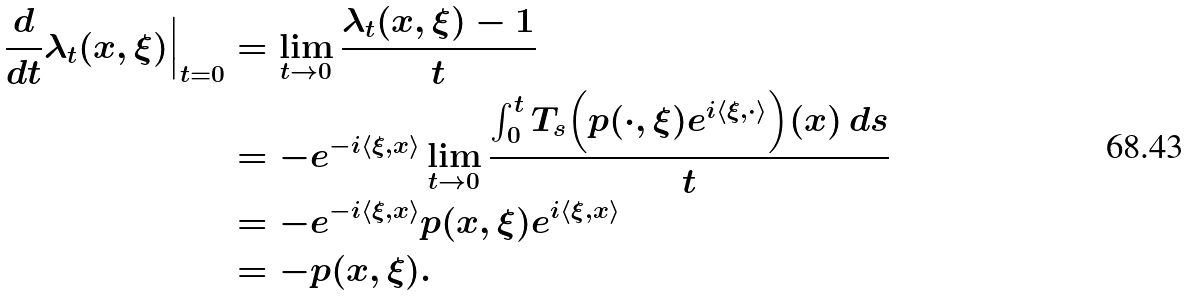Convert formula to latex. <formula><loc_0><loc_0><loc_500><loc_500>\frac { d } { d t } \lambda _ { t } ( x , \xi ) \Big | _ { t = 0 } & = \lim _ { t \to 0 } \frac { \lambda _ { t } ( x , \xi ) - 1 } { t } \\ & = - e ^ { - i \langle \xi , x \rangle } \lim _ { t \to 0 } \frac { \int _ { 0 } ^ { t } T _ { s } \Big ( p ( \cdot , \xi ) e ^ { i \langle \xi , \cdot \rangle } \Big ) ( x ) \, d s } { t } \\ & = - e ^ { - i \langle \xi , x \rangle } p ( x , \xi ) e ^ { i \langle \xi , x \rangle } \\ & = - p ( x , \xi ) .</formula> 